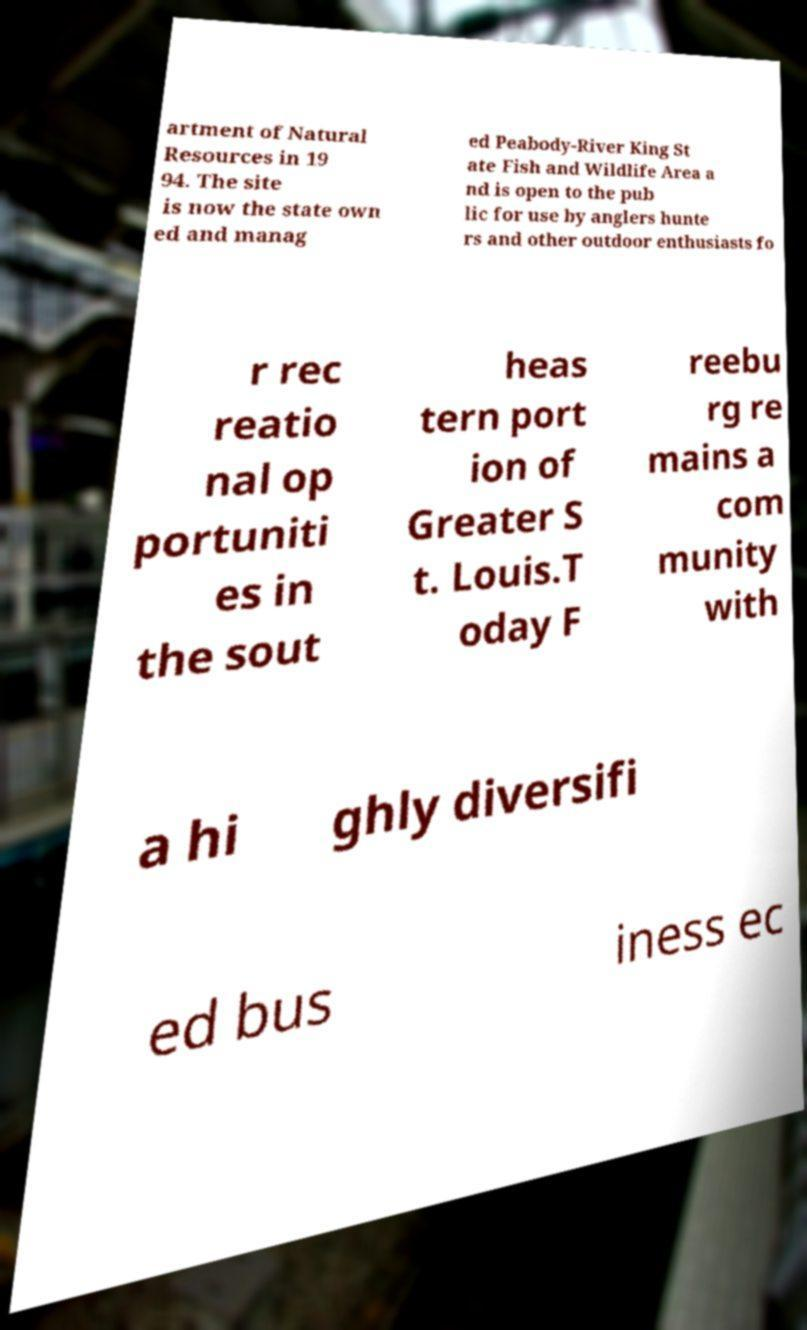Please read and relay the text visible in this image. What does it say? artment of Natural Resources in 19 94. The site is now the state own ed and manag ed Peabody-River King St ate Fish and Wildlife Area a nd is open to the pub lic for use by anglers hunte rs and other outdoor enthusiasts fo r rec reatio nal op portuniti es in the sout heas tern port ion of Greater S t. Louis.T oday F reebu rg re mains a com munity with a hi ghly diversifi ed bus iness ec 